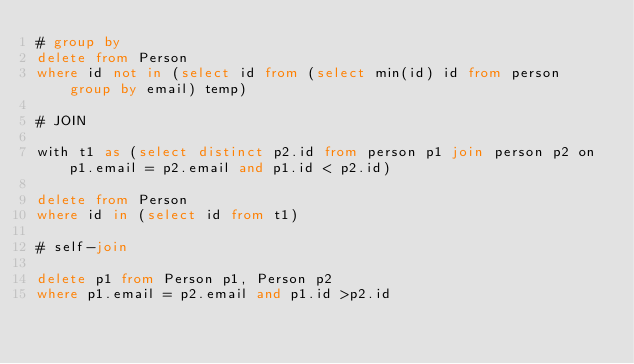Convert code to text. <code><loc_0><loc_0><loc_500><loc_500><_SQL_># group by
delete from Person
where id not in (select id from (select min(id) id from person group by email) temp)

# JOIN

with t1 as (select distinct p2.id from person p1 join person p2 on p1.email = p2.email and p1.id < p2.id)

delete from Person
where id in (select id from t1)

# self-join

delete p1 from Person p1, Person p2
where p1.email = p2.email and p1.id >p2.id</code> 